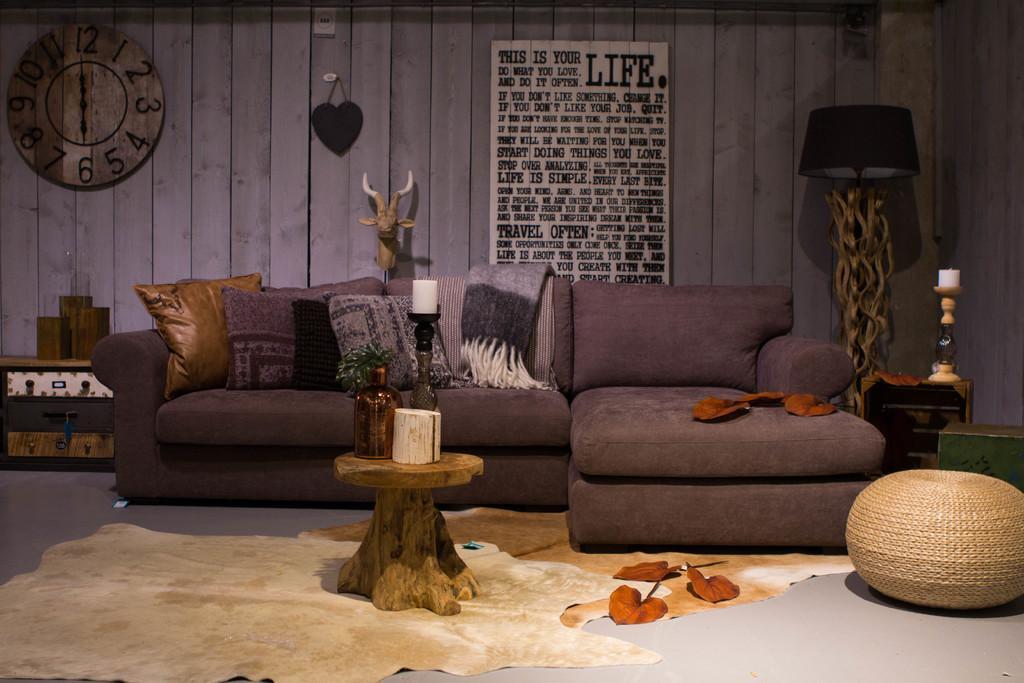In one or two sentences, can you explain what this image depicts? This is an image clicked inside the room. In this I can see a sofa in the middle of the room. In the background there is a wall, one clock and one banner is fixed to the wall. On the right and left side of the image there are some small tables. Beside the table there is a lamp. 